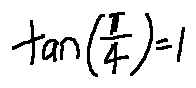Convert formula to latex. <formula><loc_0><loc_0><loc_500><loc_500>\tan ( \frac { \pi } { 4 } ) = 1</formula> 